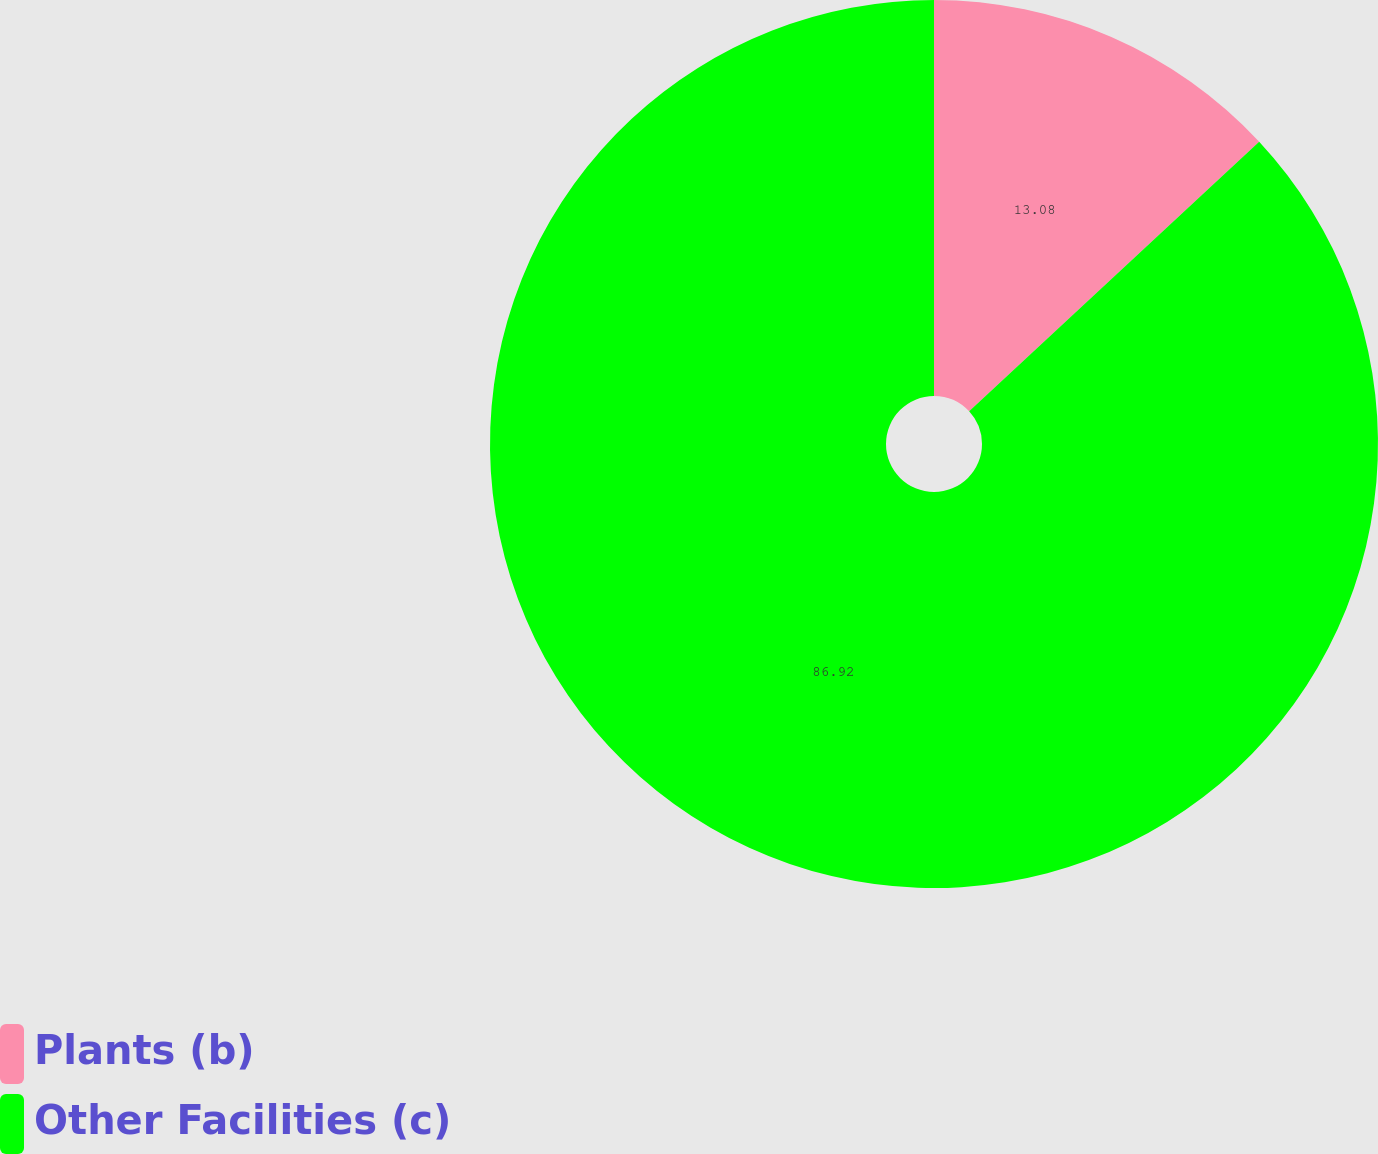Convert chart. <chart><loc_0><loc_0><loc_500><loc_500><pie_chart><fcel>Plants (b)<fcel>Other Facilities (c)<nl><fcel>13.08%<fcel>86.92%<nl></chart> 